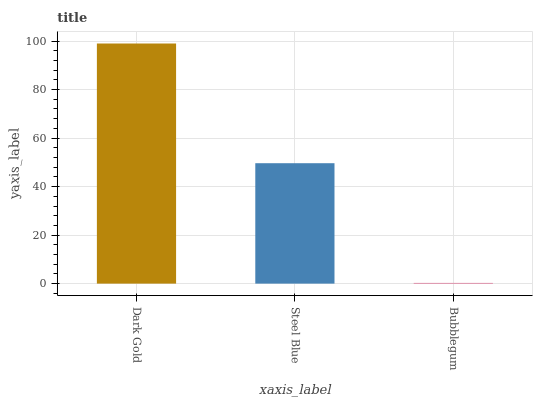Is Bubblegum the minimum?
Answer yes or no. Yes. Is Dark Gold the maximum?
Answer yes or no. Yes. Is Steel Blue the minimum?
Answer yes or no. No. Is Steel Blue the maximum?
Answer yes or no. No. Is Dark Gold greater than Steel Blue?
Answer yes or no. Yes. Is Steel Blue less than Dark Gold?
Answer yes or no. Yes. Is Steel Blue greater than Dark Gold?
Answer yes or no. No. Is Dark Gold less than Steel Blue?
Answer yes or no. No. Is Steel Blue the high median?
Answer yes or no. Yes. Is Steel Blue the low median?
Answer yes or no. Yes. Is Bubblegum the high median?
Answer yes or no. No. Is Bubblegum the low median?
Answer yes or no. No. 